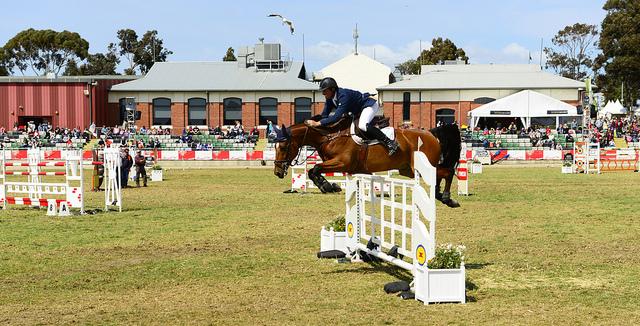Is this the Kentucky Derby?
Be succinct. No. Is there a person on this horse?
Give a very brief answer. Yes. Is the horse leaping?
Quick response, please. Yes. 